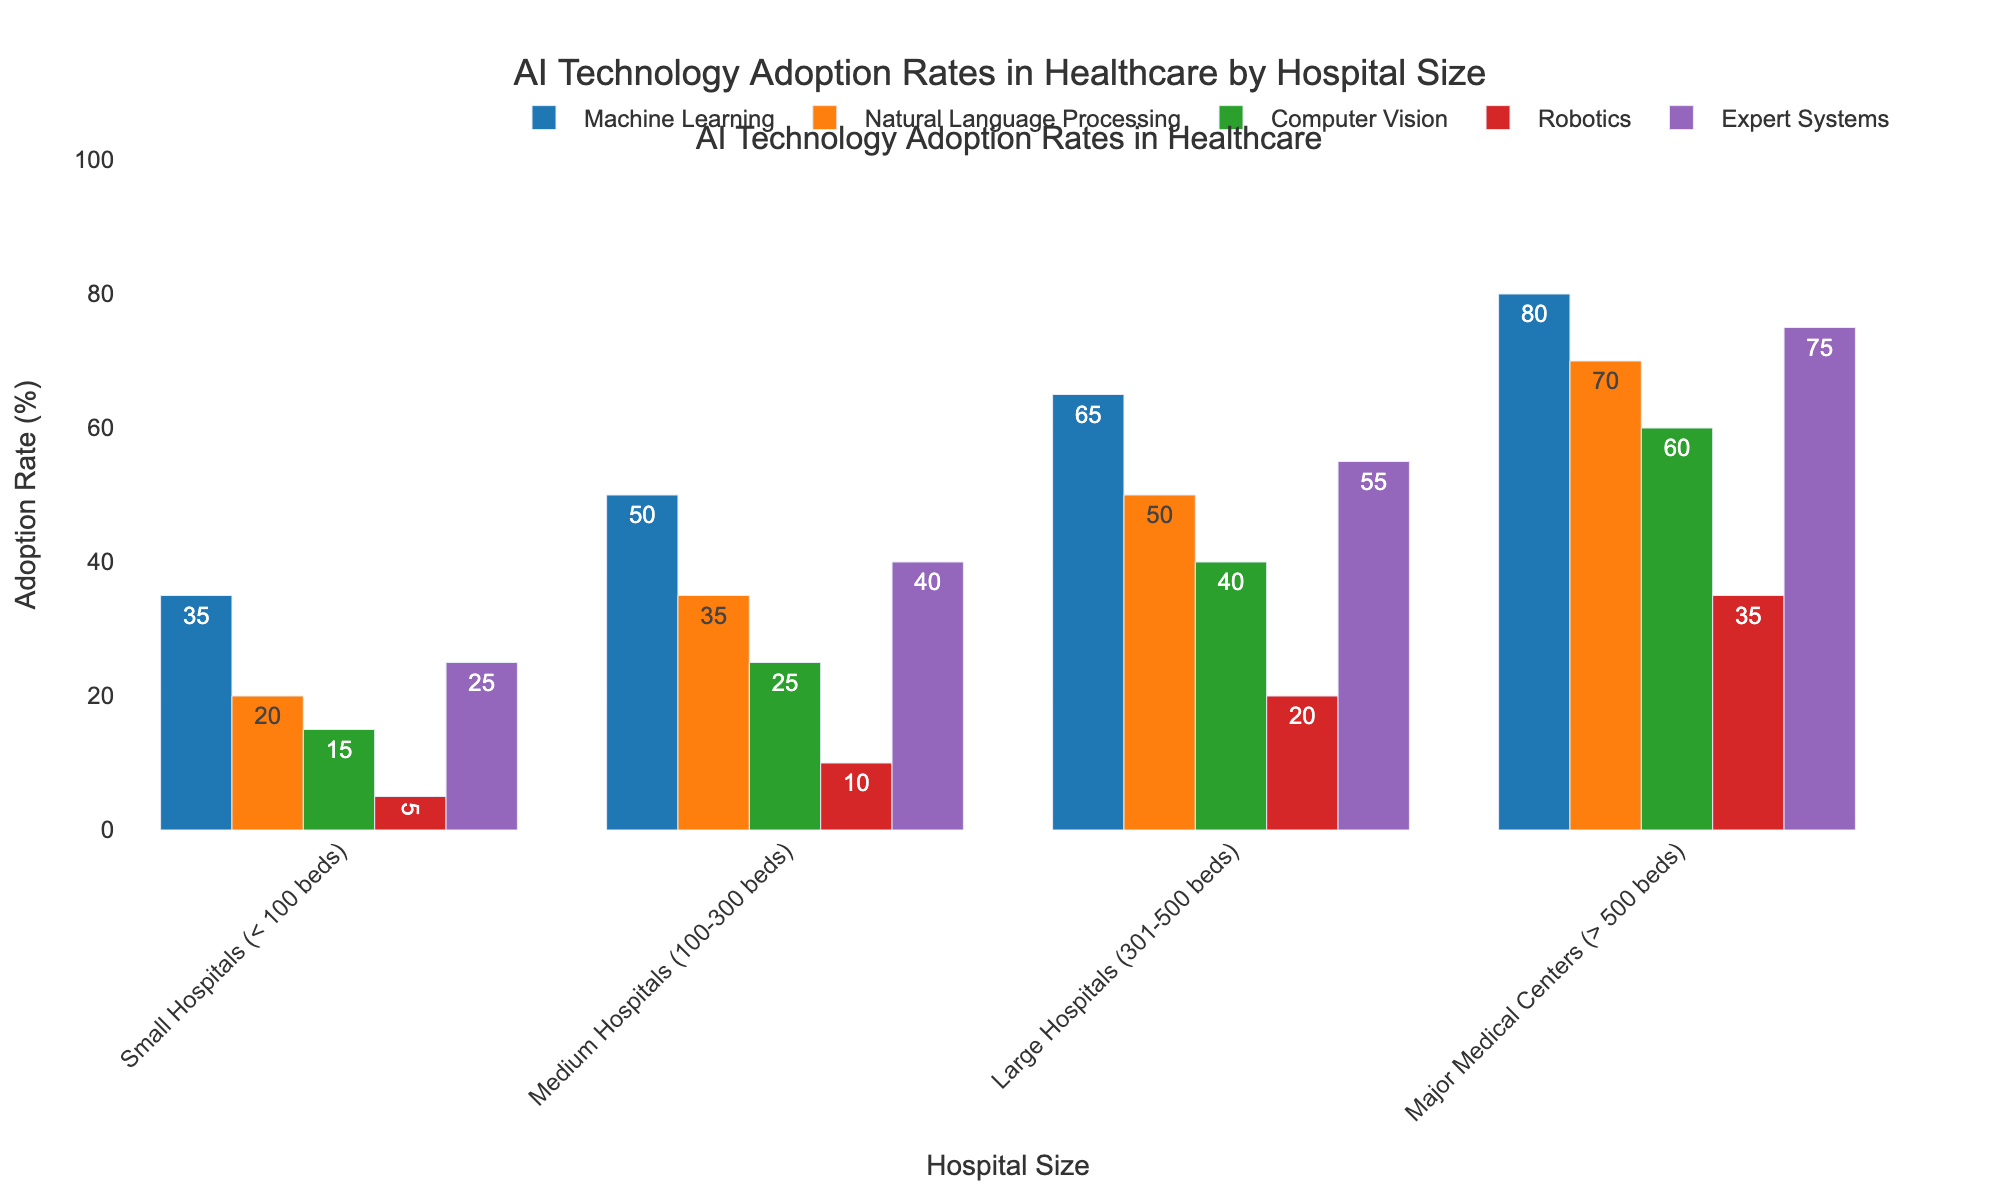What is the adoption rate of Machine Learning in Major Medical Centers? The bar for Machine Learning in Major Medical Centers corresponds to a value of 80%.
Answer: 80% Which AI technology has the lowest adoption rate in Small Hospitals? By comparing the heights of the bars for Small Hospitals, Robotics has the lowest adoption rate at 5%.
Answer: Robotics How does the adoption rate of Natural Language Processing in Medium Hospitals compare to that in Large Hospitals? The bar for Natural Language Processing in Medium Hospitals is at 35%, while in Large Hospitals, it is at 50%.
Answer: Medium Hospitals: 35%, Large Hospitals: 50% What is the total adoption rate of Computer Vision and Expert Systems in Major Medical Centers? The adoption rate of Computer Vision in Major Medical Centers is 60% and Expert Systems is 75%. Summing these rates (60 + 75) gives a total of 135%.
Answer: 135% Which hospital size demonstrates the highest adoption rate for Robotics? The highest bar for Robotics is in Major Medical Centers, which corresponds to an adoption rate of 35%.
Answer: Major Medical Centers What is the average adoption rate of all AI technologies in Small Hospitals? The adoption rates in Small Hospitals are Machine Learning: 35%, Natural Language Processing: 20%, Computer Vision: 15%, Robotics: 5%, and Expert Systems: 25%. Calculating the average: (35 + 20 + 15 + 5 + 25) / 5 = 20%.
Answer: 20% Which AI technology shows the highest adoption rate across all hospital sizes? By observing all the bars, Expert Systems has the highest adoption rate of 75% in Major Medical Centers.
Answer: Expert Systems Compare the adoption rates of Machine Learning and Natural Language Processing in Medium Hospitals. The bar for Machine Learning in Medium Hospitals is at 50%, and for Natural Language Processing, it is at 35%. Machine Learning has a higher adoption rate.
Answer: Machine Learning: 50%, Natural Language Processing: 35% What is the difference in the adoption rate of Computer Vision between Small Hospitals and Major Medical Centers? The Computer Vision adoption rates are 15% in Small Hospitals and 60% in Major Medical Centers. The difference is 60 - 15 = 45%.
Answer: 45% In Large Hospitals, which AI technology has an adoption rate closest to the average adoption rate of all technologies in Major Medical Centers? First, calculate the average adoption rate for Major Medical Centers: (80 + 70 + 60 + 35 + 75) / 5 = 64%. The adoption rates in Large Hospitals are Machine Learning: 65%, Natural Language Processing: 50%, Computer Vision: 40%, Robotics: 20%, and Expert Systems: 55%. Machine Learning at 65% is closest to 64%.
Answer: Machine Learning 